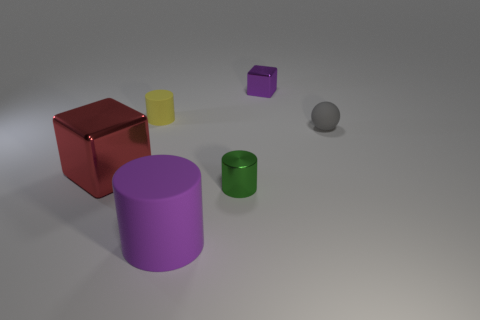There is a yellow object that is the same size as the gray rubber object; what is its shape?
Give a very brief answer. Cylinder. Is there any other thing that has the same color as the small block?
Provide a succinct answer. Yes. There is a cube on the left side of the purple shiny block to the right of the small yellow rubber cylinder; how many small purple cubes are behind it?
Provide a succinct answer. 1. Does the tiny thing behind the yellow matte cylinder have the same shape as the red thing?
Your response must be concise. Yes. What number of things are either green cylinders or rubber objects that are in front of the gray matte thing?
Offer a very short reply. 2. Are there more yellow matte cylinders that are behind the big block than large purple shiny things?
Your response must be concise. Yes. Is the number of small cylinders behind the sphere the same as the number of tiny metal blocks right of the green object?
Ensure brevity in your answer.  Yes. There is a small thing to the right of the small metallic cube; are there any red cubes on the left side of it?
Keep it short and to the point. Yes. What shape is the big purple matte thing?
Ensure brevity in your answer.  Cylinder. What is the size of the thing that is the same color as the large cylinder?
Offer a very short reply. Small. 